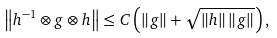Convert formula to latex. <formula><loc_0><loc_0><loc_500><loc_500>\left \| h ^ { - 1 } \otimes g \otimes h \right \| \leq C \left ( \left \| g \right \| + \sqrt { \left \| h \right \| \left \| g \right \| } \right ) ,</formula> 